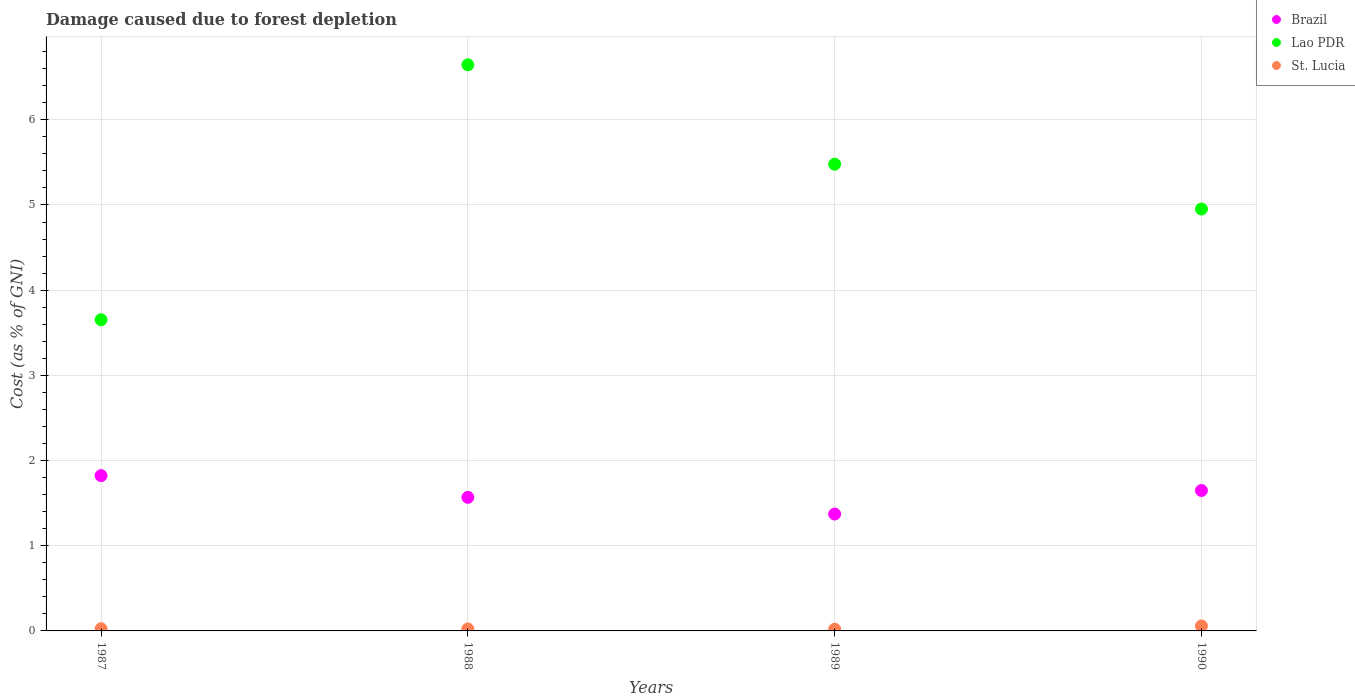How many different coloured dotlines are there?
Provide a succinct answer. 3. What is the cost of damage caused due to forest depletion in St. Lucia in 1987?
Ensure brevity in your answer.  0.03. Across all years, what is the maximum cost of damage caused due to forest depletion in St. Lucia?
Give a very brief answer. 0.06. Across all years, what is the minimum cost of damage caused due to forest depletion in Lao PDR?
Your response must be concise. 3.65. In which year was the cost of damage caused due to forest depletion in Brazil minimum?
Ensure brevity in your answer.  1989. What is the total cost of damage caused due to forest depletion in St. Lucia in the graph?
Give a very brief answer. 0.13. What is the difference between the cost of damage caused due to forest depletion in Lao PDR in 1987 and that in 1988?
Provide a short and direct response. -2.99. What is the difference between the cost of damage caused due to forest depletion in St. Lucia in 1988 and the cost of damage caused due to forest depletion in Lao PDR in 1989?
Your response must be concise. -5.46. What is the average cost of damage caused due to forest depletion in St. Lucia per year?
Provide a short and direct response. 0.03. In the year 1988, what is the difference between the cost of damage caused due to forest depletion in Brazil and cost of damage caused due to forest depletion in St. Lucia?
Give a very brief answer. 1.54. What is the ratio of the cost of damage caused due to forest depletion in Lao PDR in 1987 to that in 1990?
Your response must be concise. 0.74. Is the difference between the cost of damage caused due to forest depletion in Brazil in 1987 and 1989 greater than the difference between the cost of damage caused due to forest depletion in St. Lucia in 1987 and 1989?
Your answer should be very brief. Yes. What is the difference between the highest and the second highest cost of damage caused due to forest depletion in Lao PDR?
Offer a very short reply. 1.17. What is the difference between the highest and the lowest cost of damage caused due to forest depletion in Brazil?
Keep it short and to the point. 0.45. Is the sum of the cost of damage caused due to forest depletion in Lao PDR in 1987 and 1988 greater than the maximum cost of damage caused due to forest depletion in St. Lucia across all years?
Your response must be concise. Yes. Is it the case that in every year, the sum of the cost of damage caused due to forest depletion in St. Lucia and cost of damage caused due to forest depletion in Brazil  is greater than the cost of damage caused due to forest depletion in Lao PDR?
Keep it short and to the point. No. Is the cost of damage caused due to forest depletion in Brazil strictly greater than the cost of damage caused due to forest depletion in St. Lucia over the years?
Provide a succinct answer. Yes. Is the cost of damage caused due to forest depletion in Brazil strictly less than the cost of damage caused due to forest depletion in St. Lucia over the years?
Your answer should be very brief. No. How many dotlines are there?
Your response must be concise. 3. What is the difference between two consecutive major ticks on the Y-axis?
Provide a succinct answer. 1. Are the values on the major ticks of Y-axis written in scientific E-notation?
Make the answer very short. No. Does the graph contain any zero values?
Your answer should be very brief. No. Does the graph contain grids?
Offer a very short reply. Yes. How many legend labels are there?
Make the answer very short. 3. What is the title of the graph?
Your answer should be compact. Damage caused due to forest depletion. Does "Slovenia" appear as one of the legend labels in the graph?
Provide a succinct answer. No. What is the label or title of the Y-axis?
Offer a very short reply. Cost (as % of GNI). What is the Cost (as % of GNI) of Brazil in 1987?
Make the answer very short. 1.82. What is the Cost (as % of GNI) in Lao PDR in 1987?
Offer a terse response. 3.65. What is the Cost (as % of GNI) in St. Lucia in 1987?
Keep it short and to the point. 0.03. What is the Cost (as % of GNI) of Brazil in 1988?
Offer a terse response. 1.57. What is the Cost (as % of GNI) of Lao PDR in 1988?
Provide a short and direct response. 6.65. What is the Cost (as % of GNI) of St. Lucia in 1988?
Your answer should be compact. 0.02. What is the Cost (as % of GNI) in Brazil in 1989?
Your answer should be very brief. 1.37. What is the Cost (as % of GNI) in Lao PDR in 1989?
Offer a very short reply. 5.48. What is the Cost (as % of GNI) in St. Lucia in 1989?
Provide a short and direct response. 0.02. What is the Cost (as % of GNI) of Brazil in 1990?
Your answer should be compact. 1.65. What is the Cost (as % of GNI) of Lao PDR in 1990?
Keep it short and to the point. 4.95. What is the Cost (as % of GNI) in St. Lucia in 1990?
Your answer should be compact. 0.06. Across all years, what is the maximum Cost (as % of GNI) in Brazil?
Your answer should be very brief. 1.82. Across all years, what is the maximum Cost (as % of GNI) in Lao PDR?
Keep it short and to the point. 6.65. Across all years, what is the maximum Cost (as % of GNI) of St. Lucia?
Your response must be concise. 0.06. Across all years, what is the minimum Cost (as % of GNI) of Brazil?
Give a very brief answer. 1.37. Across all years, what is the minimum Cost (as % of GNI) of Lao PDR?
Your response must be concise. 3.65. Across all years, what is the minimum Cost (as % of GNI) of St. Lucia?
Your answer should be very brief. 0.02. What is the total Cost (as % of GNI) in Brazil in the graph?
Give a very brief answer. 6.41. What is the total Cost (as % of GNI) in Lao PDR in the graph?
Give a very brief answer. 20.73. What is the total Cost (as % of GNI) of St. Lucia in the graph?
Make the answer very short. 0.13. What is the difference between the Cost (as % of GNI) in Brazil in 1987 and that in 1988?
Make the answer very short. 0.26. What is the difference between the Cost (as % of GNI) in Lao PDR in 1987 and that in 1988?
Provide a succinct answer. -2.99. What is the difference between the Cost (as % of GNI) in St. Lucia in 1987 and that in 1988?
Give a very brief answer. 0. What is the difference between the Cost (as % of GNI) in Brazil in 1987 and that in 1989?
Your response must be concise. 0.45. What is the difference between the Cost (as % of GNI) in Lao PDR in 1987 and that in 1989?
Make the answer very short. -1.83. What is the difference between the Cost (as % of GNI) in St. Lucia in 1987 and that in 1989?
Give a very brief answer. 0.01. What is the difference between the Cost (as % of GNI) in Brazil in 1987 and that in 1990?
Give a very brief answer. 0.17. What is the difference between the Cost (as % of GNI) in Lao PDR in 1987 and that in 1990?
Give a very brief answer. -1.3. What is the difference between the Cost (as % of GNI) in St. Lucia in 1987 and that in 1990?
Keep it short and to the point. -0.03. What is the difference between the Cost (as % of GNI) of Brazil in 1988 and that in 1989?
Your answer should be compact. 0.2. What is the difference between the Cost (as % of GNI) of Lao PDR in 1988 and that in 1989?
Your answer should be compact. 1.17. What is the difference between the Cost (as % of GNI) in St. Lucia in 1988 and that in 1989?
Offer a terse response. 0. What is the difference between the Cost (as % of GNI) of Brazil in 1988 and that in 1990?
Provide a succinct answer. -0.08. What is the difference between the Cost (as % of GNI) in Lao PDR in 1988 and that in 1990?
Offer a very short reply. 1.69. What is the difference between the Cost (as % of GNI) in St. Lucia in 1988 and that in 1990?
Your answer should be very brief. -0.04. What is the difference between the Cost (as % of GNI) in Brazil in 1989 and that in 1990?
Your response must be concise. -0.28. What is the difference between the Cost (as % of GNI) in Lao PDR in 1989 and that in 1990?
Offer a terse response. 0.53. What is the difference between the Cost (as % of GNI) in St. Lucia in 1989 and that in 1990?
Your answer should be very brief. -0.04. What is the difference between the Cost (as % of GNI) of Brazil in 1987 and the Cost (as % of GNI) of Lao PDR in 1988?
Offer a very short reply. -4.82. What is the difference between the Cost (as % of GNI) of Brazil in 1987 and the Cost (as % of GNI) of St. Lucia in 1988?
Keep it short and to the point. 1.8. What is the difference between the Cost (as % of GNI) of Lao PDR in 1987 and the Cost (as % of GNI) of St. Lucia in 1988?
Make the answer very short. 3.63. What is the difference between the Cost (as % of GNI) of Brazil in 1987 and the Cost (as % of GNI) of Lao PDR in 1989?
Provide a short and direct response. -3.66. What is the difference between the Cost (as % of GNI) of Brazil in 1987 and the Cost (as % of GNI) of St. Lucia in 1989?
Your response must be concise. 1.8. What is the difference between the Cost (as % of GNI) in Lao PDR in 1987 and the Cost (as % of GNI) in St. Lucia in 1989?
Provide a succinct answer. 3.63. What is the difference between the Cost (as % of GNI) of Brazil in 1987 and the Cost (as % of GNI) of Lao PDR in 1990?
Offer a very short reply. -3.13. What is the difference between the Cost (as % of GNI) of Brazil in 1987 and the Cost (as % of GNI) of St. Lucia in 1990?
Provide a short and direct response. 1.76. What is the difference between the Cost (as % of GNI) of Lao PDR in 1987 and the Cost (as % of GNI) of St. Lucia in 1990?
Offer a very short reply. 3.59. What is the difference between the Cost (as % of GNI) of Brazil in 1988 and the Cost (as % of GNI) of Lao PDR in 1989?
Your answer should be compact. -3.91. What is the difference between the Cost (as % of GNI) in Brazil in 1988 and the Cost (as % of GNI) in St. Lucia in 1989?
Provide a short and direct response. 1.55. What is the difference between the Cost (as % of GNI) of Lao PDR in 1988 and the Cost (as % of GNI) of St. Lucia in 1989?
Offer a terse response. 6.63. What is the difference between the Cost (as % of GNI) in Brazil in 1988 and the Cost (as % of GNI) in Lao PDR in 1990?
Your answer should be very brief. -3.38. What is the difference between the Cost (as % of GNI) of Brazil in 1988 and the Cost (as % of GNI) of St. Lucia in 1990?
Offer a terse response. 1.51. What is the difference between the Cost (as % of GNI) of Lao PDR in 1988 and the Cost (as % of GNI) of St. Lucia in 1990?
Offer a terse response. 6.59. What is the difference between the Cost (as % of GNI) of Brazil in 1989 and the Cost (as % of GNI) of Lao PDR in 1990?
Your answer should be very brief. -3.58. What is the difference between the Cost (as % of GNI) of Brazil in 1989 and the Cost (as % of GNI) of St. Lucia in 1990?
Ensure brevity in your answer.  1.31. What is the difference between the Cost (as % of GNI) of Lao PDR in 1989 and the Cost (as % of GNI) of St. Lucia in 1990?
Keep it short and to the point. 5.42. What is the average Cost (as % of GNI) of Brazil per year?
Offer a very short reply. 1.6. What is the average Cost (as % of GNI) in Lao PDR per year?
Ensure brevity in your answer.  5.18. What is the average Cost (as % of GNI) in St. Lucia per year?
Provide a short and direct response. 0.03. In the year 1987, what is the difference between the Cost (as % of GNI) in Brazil and Cost (as % of GNI) in Lao PDR?
Your answer should be compact. -1.83. In the year 1987, what is the difference between the Cost (as % of GNI) in Brazil and Cost (as % of GNI) in St. Lucia?
Your answer should be very brief. 1.8. In the year 1987, what is the difference between the Cost (as % of GNI) in Lao PDR and Cost (as % of GNI) in St. Lucia?
Your answer should be very brief. 3.63. In the year 1988, what is the difference between the Cost (as % of GNI) of Brazil and Cost (as % of GNI) of Lao PDR?
Provide a short and direct response. -5.08. In the year 1988, what is the difference between the Cost (as % of GNI) in Brazil and Cost (as % of GNI) in St. Lucia?
Provide a short and direct response. 1.54. In the year 1988, what is the difference between the Cost (as % of GNI) of Lao PDR and Cost (as % of GNI) of St. Lucia?
Keep it short and to the point. 6.62. In the year 1989, what is the difference between the Cost (as % of GNI) in Brazil and Cost (as % of GNI) in Lao PDR?
Your answer should be compact. -4.11. In the year 1989, what is the difference between the Cost (as % of GNI) in Brazil and Cost (as % of GNI) in St. Lucia?
Ensure brevity in your answer.  1.35. In the year 1989, what is the difference between the Cost (as % of GNI) of Lao PDR and Cost (as % of GNI) of St. Lucia?
Make the answer very short. 5.46. In the year 1990, what is the difference between the Cost (as % of GNI) of Brazil and Cost (as % of GNI) of Lao PDR?
Your answer should be compact. -3.3. In the year 1990, what is the difference between the Cost (as % of GNI) of Brazil and Cost (as % of GNI) of St. Lucia?
Keep it short and to the point. 1.59. In the year 1990, what is the difference between the Cost (as % of GNI) in Lao PDR and Cost (as % of GNI) in St. Lucia?
Provide a short and direct response. 4.89. What is the ratio of the Cost (as % of GNI) of Brazil in 1987 to that in 1988?
Your response must be concise. 1.16. What is the ratio of the Cost (as % of GNI) in Lao PDR in 1987 to that in 1988?
Offer a very short reply. 0.55. What is the ratio of the Cost (as % of GNI) of St. Lucia in 1987 to that in 1988?
Your answer should be very brief. 1.12. What is the ratio of the Cost (as % of GNI) of Brazil in 1987 to that in 1989?
Provide a succinct answer. 1.33. What is the ratio of the Cost (as % of GNI) of Lao PDR in 1987 to that in 1989?
Offer a very short reply. 0.67. What is the ratio of the Cost (as % of GNI) in St. Lucia in 1987 to that in 1989?
Provide a short and direct response. 1.28. What is the ratio of the Cost (as % of GNI) in Brazil in 1987 to that in 1990?
Give a very brief answer. 1.11. What is the ratio of the Cost (as % of GNI) of Lao PDR in 1987 to that in 1990?
Keep it short and to the point. 0.74. What is the ratio of the Cost (as % of GNI) in St. Lucia in 1987 to that in 1990?
Make the answer very short. 0.44. What is the ratio of the Cost (as % of GNI) of Lao PDR in 1988 to that in 1989?
Offer a terse response. 1.21. What is the ratio of the Cost (as % of GNI) of St. Lucia in 1988 to that in 1989?
Ensure brevity in your answer.  1.14. What is the ratio of the Cost (as % of GNI) in Brazil in 1988 to that in 1990?
Give a very brief answer. 0.95. What is the ratio of the Cost (as % of GNI) of Lao PDR in 1988 to that in 1990?
Your answer should be compact. 1.34. What is the ratio of the Cost (as % of GNI) of St. Lucia in 1988 to that in 1990?
Offer a terse response. 0.4. What is the ratio of the Cost (as % of GNI) of Brazil in 1989 to that in 1990?
Provide a succinct answer. 0.83. What is the ratio of the Cost (as % of GNI) of Lao PDR in 1989 to that in 1990?
Your answer should be very brief. 1.11. What is the ratio of the Cost (as % of GNI) of St. Lucia in 1989 to that in 1990?
Keep it short and to the point. 0.35. What is the difference between the highest and the second highest Cost (as % of GNI) of Brazil?
Offer a very short reply. 0.17. What is the difference between the highest and the second highest Cost (as % of GNI) of Lao PDR?
Give a very brief answer. 1.17. What is the difference between the highest and the second highest Cost (as % of GNI) in St. Lucia?
Your response must be concise. 0.03. What is the difference between the highest and the lowest Cost (as % of GNI) in Brazil?
Keep it short and to the point. 0.45. What is the difference between the highest and the lowest Cost (as % of GNI) of Lao PDR?
Give a very brief answer. 2.99. What is the difference between the highest and the lowest Cost (as % of GNI) in St. Lucia?
Keep it short and to the point. 0.04. 